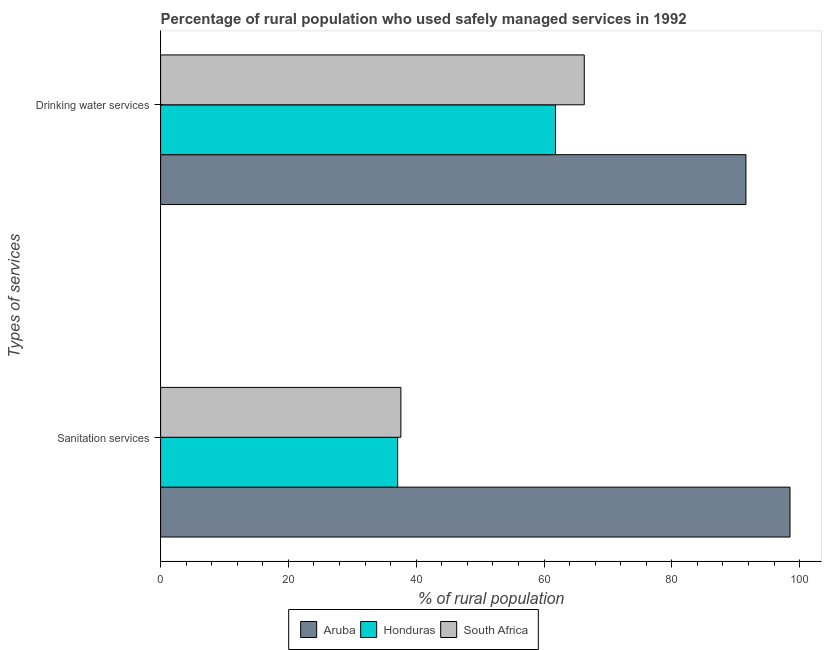How many groups of bars are there?
Provide a succinct answer. 2. How many bars are there on the 1st tick from the top?
Your answer should be compact. 3. What is the label of the 1st group of bars from the top?
Provide a short and direct response. Drinking water services. What is the percentage of rural population who used drinking water services in South Africa?
Provide a succinct answer. 66.3. Across all countries, what is the maximum percentage of rural population who used drinking water services?
Keep it short and to the point. 91.6. Across all countries, what is the minimum percentage of rural population who used drinking water services?
Your answer should be very brief. 61.8. In which country was the percentage of rural population who used sanitation services maximum?
Make the answer very short. Aruba. In which country was the percentage of rural population who used drinking water services minimum?
Provide a succinct answer. Honduras. What is the total percentage of rural population who used sanitation services in the graph?
Offer a very short reply. 173.2. What is the difference between the percentage of rural population who used sanitation services in Honduras and that in Aruba?
Keep it short and to the point. -61.4. What is the difference between the percentage of rural population who used sanitation services in Honduras and the percentage of rural population who used drinking water services in Aruba?
Keep it short and to the point. -54.5. What is the average percentage of rural population who used sanitation services per country?
Your response must be concise. 57.73. What is the difference between the percentage of rural population who used sanitation services and percentage of rural population who used drinking water services in Honduras?
Offer a terse response. -24.7. In how many countries, is the percentage of rural population who used sanitation services greater than 8 %?
Ensure brevity in your answer.  3. What is the ratio of the percentage of rural population who used sanitation services in Aruba to that in Honduras?
Keep it short and to the point. 2.65. What does the 2nd bar from the top in Sanitation services represents?
Offer a terse response. Honduras. What does the 1st bar from the bottom in Sanitation services represents?
Offer a very short reply. Aruba. How many bars are there?
Your answer should be very brief. 6. Are all the bars in the graph horizontal?
Offer a terse response. Yes. What is the difference between two consecutive major ticks on the X-axis?
Offer a terse response. 20. Does the graph contain grids?
Provide a succinct answer. No. What is the title of the graph?
Ensure brevity in your answer.  Percentage of rural population who used safely managed services in 1992. Does "Azerbaijan" appear as one of the legend labels in the graph?
Your answer should be very brief. No. What is the label or title of the X-axis?
Your response must be concise. % of rural population. What is the label or title of the Y-axis?
Offer a very short reply. Types of services. What is the % of rural population of Aruba in Sanitation services?
Ensure brevity in your answer.  98.5. What is the % of rural population in Honduras in Sanitation services?
Keep it short and to the point. 37.1. What is the % of rural population in South Africa in Sanitation services?
Your answer should be compact. 37.6. What is the % of rural population of Aruba in Drinking water services?
Keep it short and to the point. 91.6. What is the % of rural population of Honduras in Drinking water services?
Ensure brevity in your answer.  61.8. What is the % of rural population in South Africa in Drinking water services?
Give a very brief answer. 66.3. Across all Types of services, what is the maximum % of rural population in Aruba?
Your response must be concise. 98.5. Across all Types of services, what is the maximum % of rural population of Honduras?
Provide a succinct answer. 61.8. Across all Types of services, what is the maximum % of rural population of South Africa?
Make the answer very short. 66.3. Across all Types of services, what is the minimum % of rural population of Aruba?
Offer a very short reply. 91.6. Across all Types of services, what is the minimum % of rural population of Honduras?
Give a very brief answer. 37.1. Across all Types of services, what is the minimum % of rural population in South Africa?
Provide a succinct answer. 37.6. What is the total % of rural population in Aruba in the graph?
Your response must be concise. 190.1. What is the total % of rural population of Honduras in the graph?
Give a very brief answer. 98.9. What is the total % of rural population in South Africa in the graph?
Your answer should be compact. 103.9. What is the difference between the % of rural population of Honduras in Sanitation services and that in Drinking water services?
Your answer should be very brief. -24.7. What is the difference between the % of rural population of South Africa in Sanitation services and that in Drinking water services?
Keep it short and to the point. -28.7. What is the difference between the % of rural population of Aruba in Sanitation services and the % of rural population of Honduras in Drinking water services?
Provide a short and direct response. 36.7. What is the difference between the % of rural population in Aruba in Sanitation services and the % of rural population in South Africa in Drinking water services?
Keep it short and to the point. 32.2. What is the difference between the % of rural population of Honduras in Sanitation services and the % of rural population of South Africa in Drinking water services?
Provide a short and direct response. -29.2. What is the average % of rural population of Aruba per Types of services?
Your answer should be very brief. 95.05. What is the average % of rural population of Honduras per Types of services?
Make the answer very short. 49.45. What is the average % of rural population in South Africa per Types of services?
Provide a succinct answer. 51.95. What is the difference between the % of rural population of Aruba and % of rural population of Honduras in Sanitation services?
Make the answer very short. 61.4. What is the difference between the % of rural population of Aruba and % of rural population of South Africa in Sanitation services?
Give a very brief answer. 60.9. What is the difference between the % of rural population in Aruba and % of rural population in Honduras in Drinking water services?
Offer a terse response. 29.8. What is the difference between the % of rural population of Aruba and % of rural population of South Africa in Drinking water services?
Make the answer very short. 25.3. What is the difference between the % of rural population in Honduras and % of rural population in South Africa in Drinking water services?
Your answer should be very brief. -4.5. What is the ratio of the % of rural population of Aruba in Sanitation services to that in Drinking water services?
Offer a terse response. 1.08. What is the ratio of the % of rural population of Honduras in Sanitation services to that in Drinking water services?
Give a very brief answer. 0.6. What is the ratio of the % of rural population in South Africa in Sanitation services to that in Drinking water services?
Your answer should be very brief. 0.57. What is the difference between the highest and the second highest % of rural population of Honduras?
Offer a terse response. 24.7. What is the difference between the highest and the second highest % of rural population in South Africa?
Offer a very short reply. 28.7. What is the difference between the highest and the lowest % of rural population of Aruba?
Provide a succinct answer. 6.9. What is the difference between the highest and the lowest % of rural population in Honduras?
Your answer should be compact. 24.7. What is the difference between the highest and the lowest % of rural population of South Africa?
Your response must be concise. 28.7. 